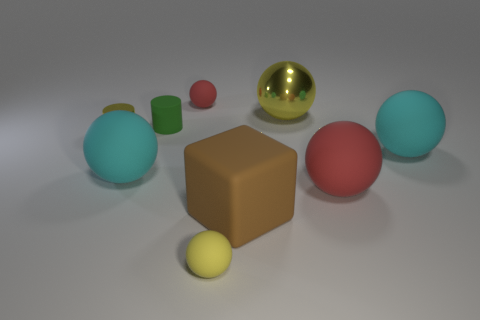How many big red rubber things are behind the rubber ball that is behind the small green thing?
Your answer should be very brief. 0. What number of cyan things are big objects or big rubber objects?
Offer a very short reply. 2. The red thing that is to the right of the red rubber ball that is to the left of the yellow ball in front of the small yellow metal cylinder is what shape?
Provide a succinct answer. Sphere. There is another metallic object that is the same size as the green thing; what is its color?
Keep it short and to the point. Yellow. What number of big brown matte things have the same shape as the green object?
Your answer should be compact. 0. There is a yellow cylinder; is its size the same as the cyan rubber sphere that is right of the green cylinder?
Give a very brief answer. No. There is a large rubber thing on the left side of the tiny green object that is behind the brown rubber object; what shape is it?
Your response must be concise. Sphere. Is the number of big rubber spheres behind the rubber cylinder less than the number of small yellow cylinders?
Your answer should be compact. Yes. What shape is the rubber object that is the same color as the metal sphere?
Provide a short and direct response. Sphere. What number of red things have the same size as the cube?
Your answer should be compact. 1. 